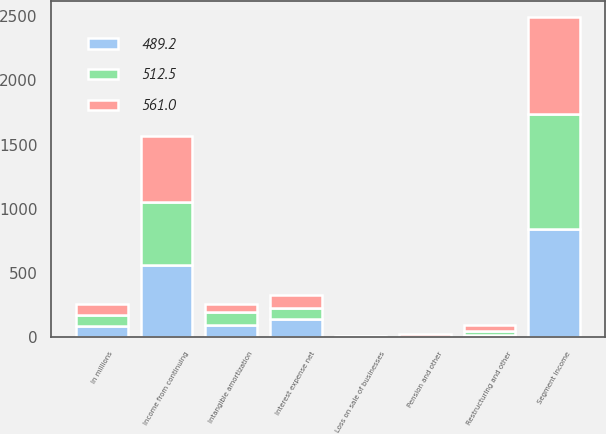Convert chart. <chart><loc_0><loc_0><loc_500><loc_500><stacked_bar_chart><ecel><fcel>In millions<fcel>Segment income<fcel>Restructuring and other<fcel>Intangible amortization<fcel>Pension and other<fcel>Loss on sale of businesses<fcel>Interest expense net<fcel>Income from continuing<nl><fcel>512.5<fcel>87.3<fcel>897.2<fcel>30.7<fcel>97.7<fcel>1.6<fcel>4.2<fcel>87.3<fcel>489.2<nl><fcel>489.2<fcel>87.3<fcel>839.5<fcel>20.6<fcel>96.4<fcel>4.2<fcel>3.9<fcel>140.1<fcel>561<nl><fcel>561<fcel>87.3<fcel>755.2<fcel>42.5<fcel>68.1<fcel>23<fcel>3.2<fcel>101.9<fcel>512.5<nl></chart> 